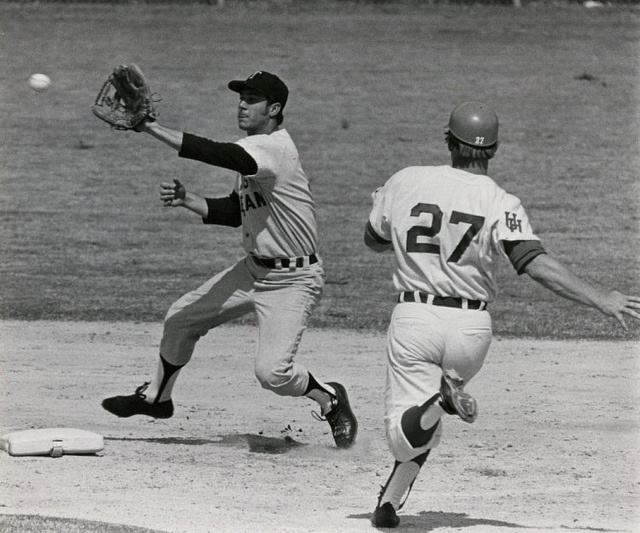Describe the objects in this image and their specific colors. I can see people in black, lightgray, darkgray, and gray tones, people in black, gray, darkgray, and lightgray tones, baseball glove in black and gray tones, and sports ball in black, darkgray, lightgray, and gray tones in this image. 